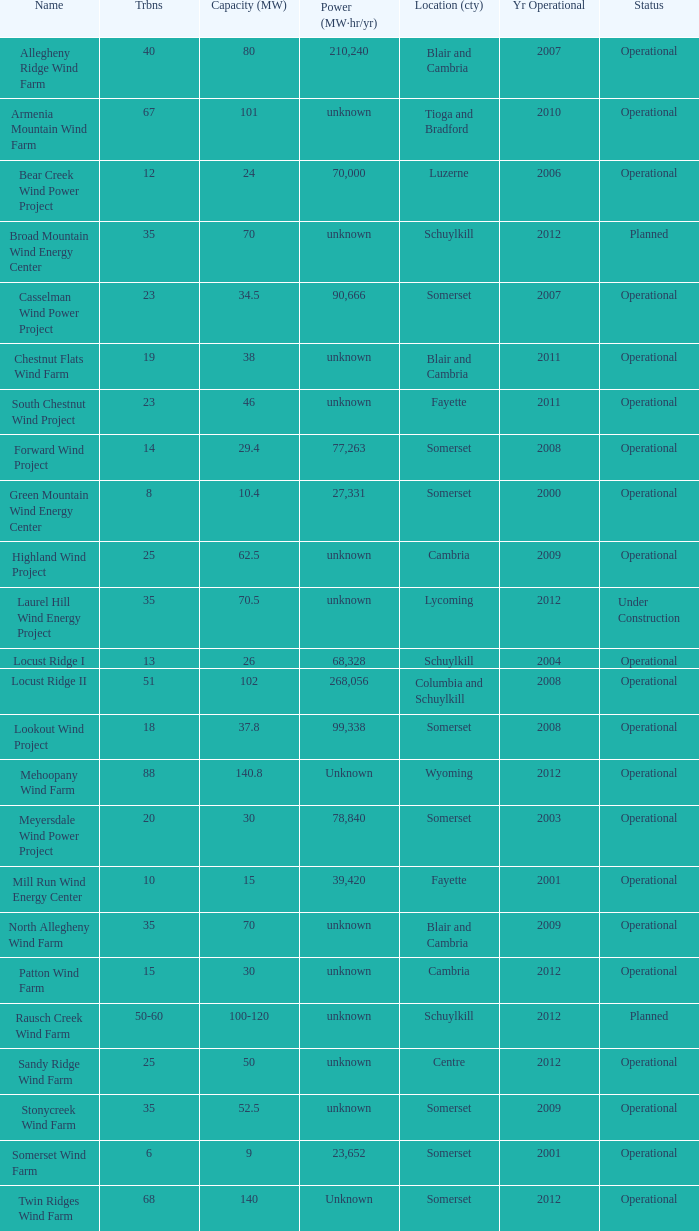What all turbines have a capacity of 30 and have a Somerset location? 20.0. 